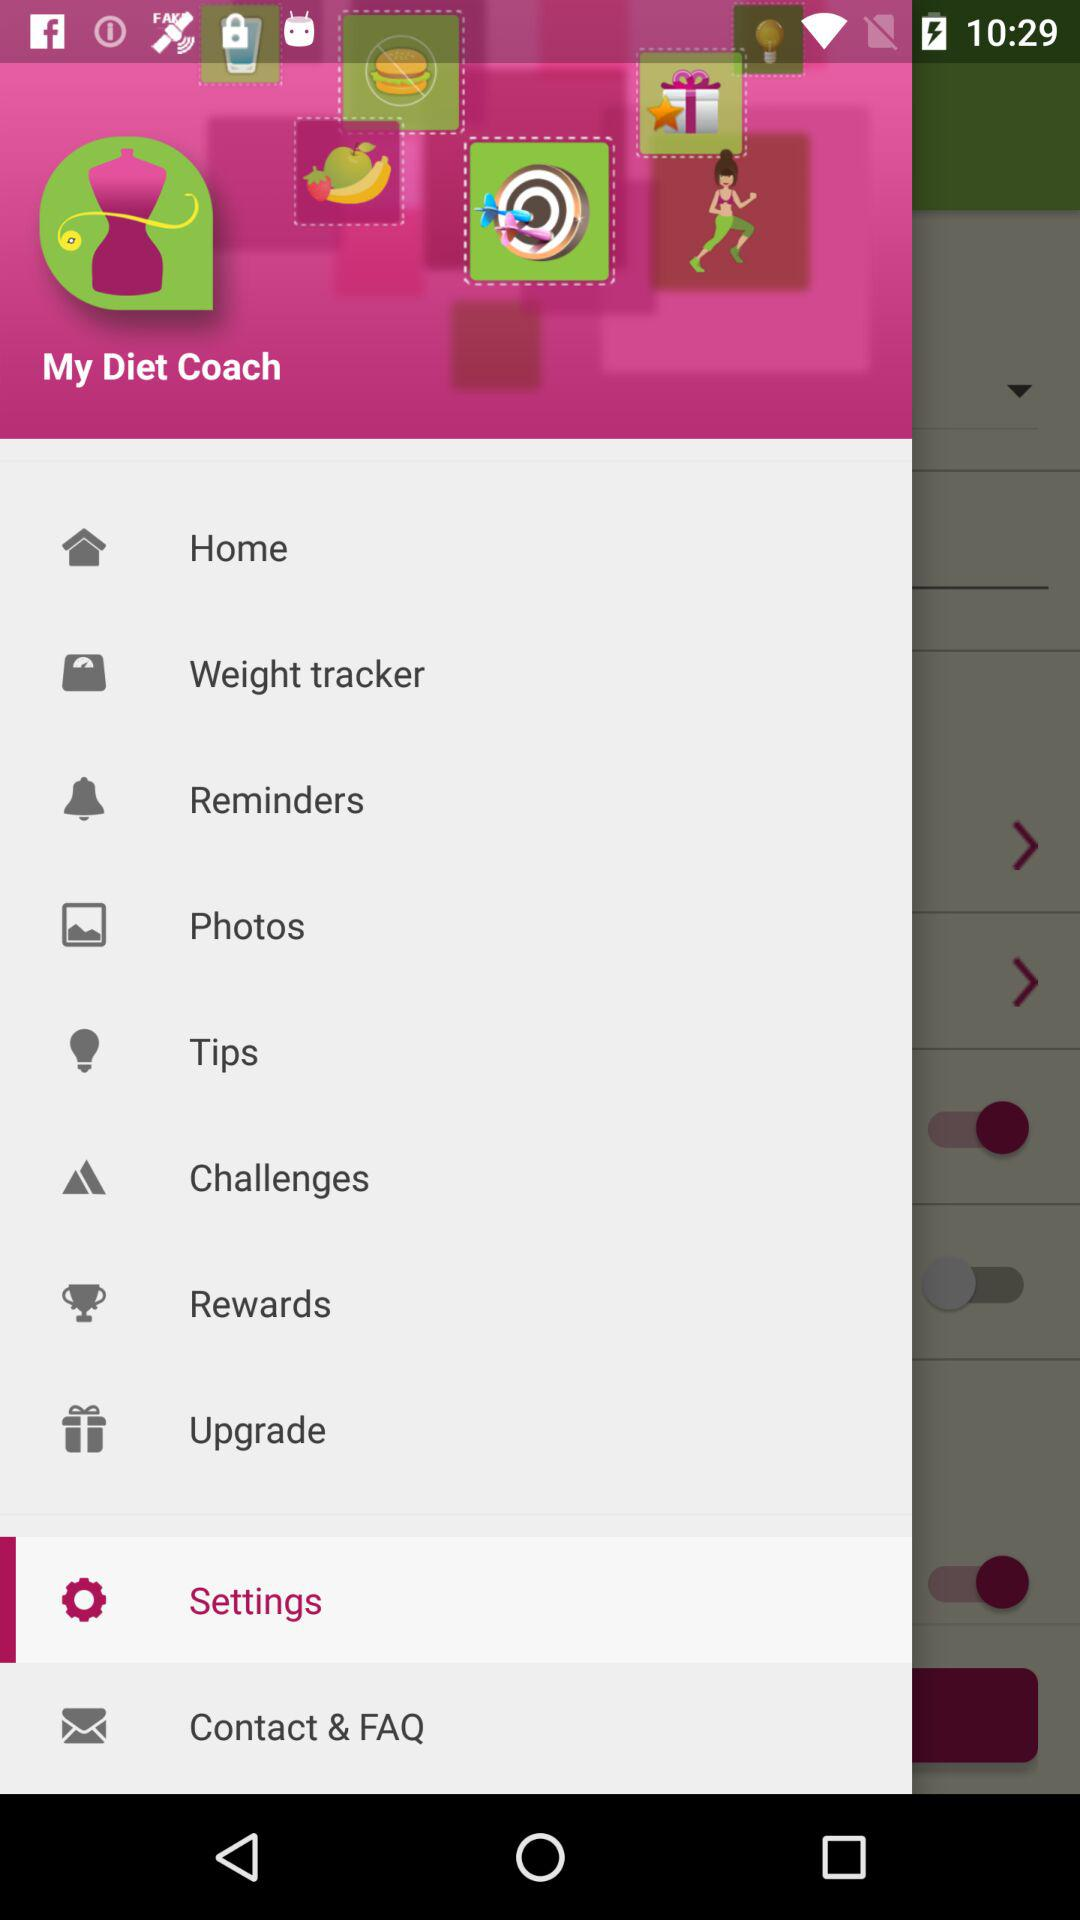What is the application name? The application name is "My Diet Coach". 